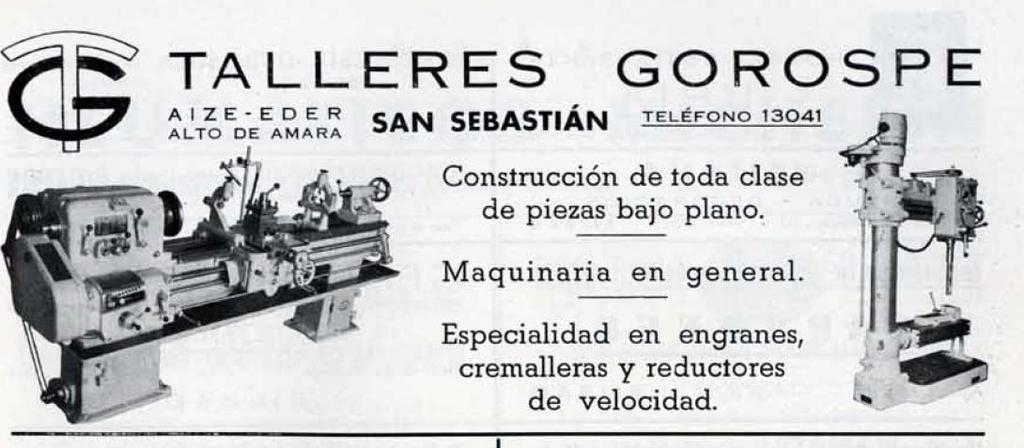What is the main subject in the center of the image? There is a poster in the center of the image. What type of images are featured on the poster? The poster contains images of machines. Is there any text on the poster? Yes, there is text on the poster. Where is the stage located in the image? There is no stage present in the image; it features a poster with images of machines and text. 